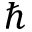Convert formula to latex. <formula><loc_0><loc_0><loc_500><loc_500>\hslash</formula> 